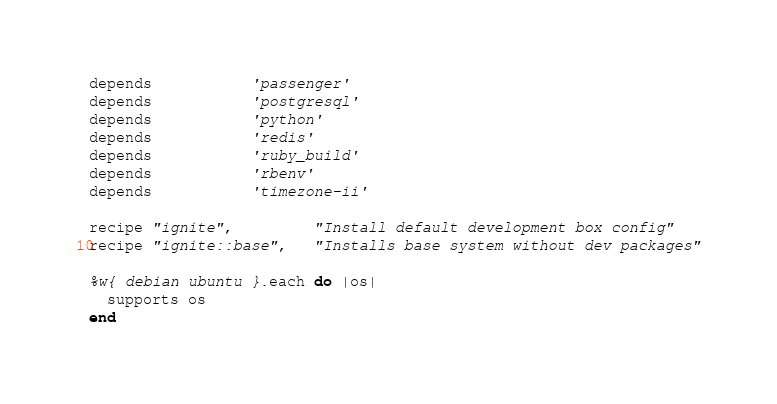<code> <loc_0><loc_0><loc_500><loc_500><_Ruby_>depends           'passenger'
depends           'postgresql'
depends           'python'
depends           'redis'
depends           'ruby_build'
depends           'rbenv'
depends           'timezone-ii'

recipe "ignite",         "Install default development box config"
recipe "ignite::base",   "Installs base system without dev packages"

%w{ debian ubuntu }.each do |os|
  supports os
end
</code> 